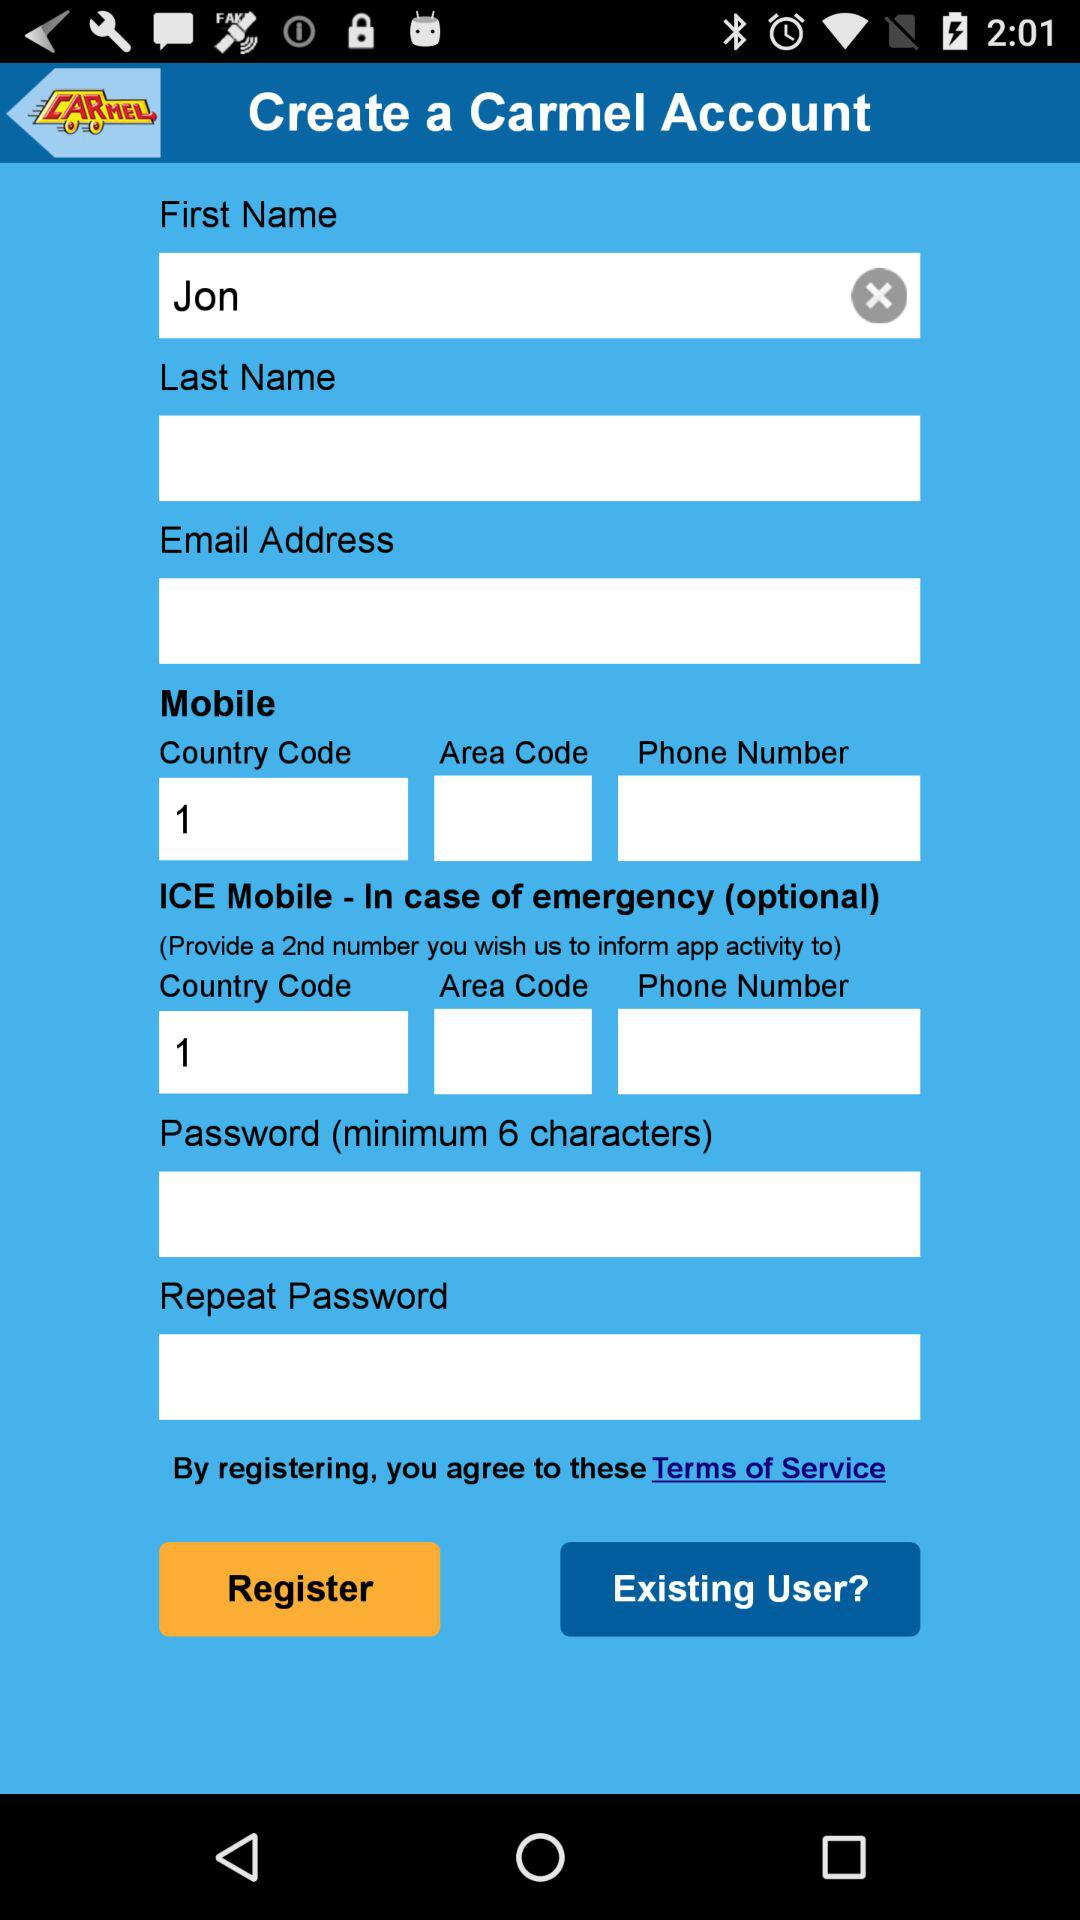What is the name of the application? The name of the application is "Carmel". 